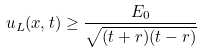<formula> <loc_0><loc_0><loc_500><loc_500>u _ { L } ( x , t ) \geq \frac { E _ { 0 } } { \sqrt { ( t + r ) ( t - r ) } }</formula> 